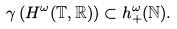Convert formula to latex. <formula><loc_0><loc_0><loc_500><loc_500>\gamma \left ( H ^ { \omega } ( \mathbb { T } , \mathbb { R } ) \right ) \subset h _ { + } ^ { \omega } ( \mathbb { N } ) .</formula> 